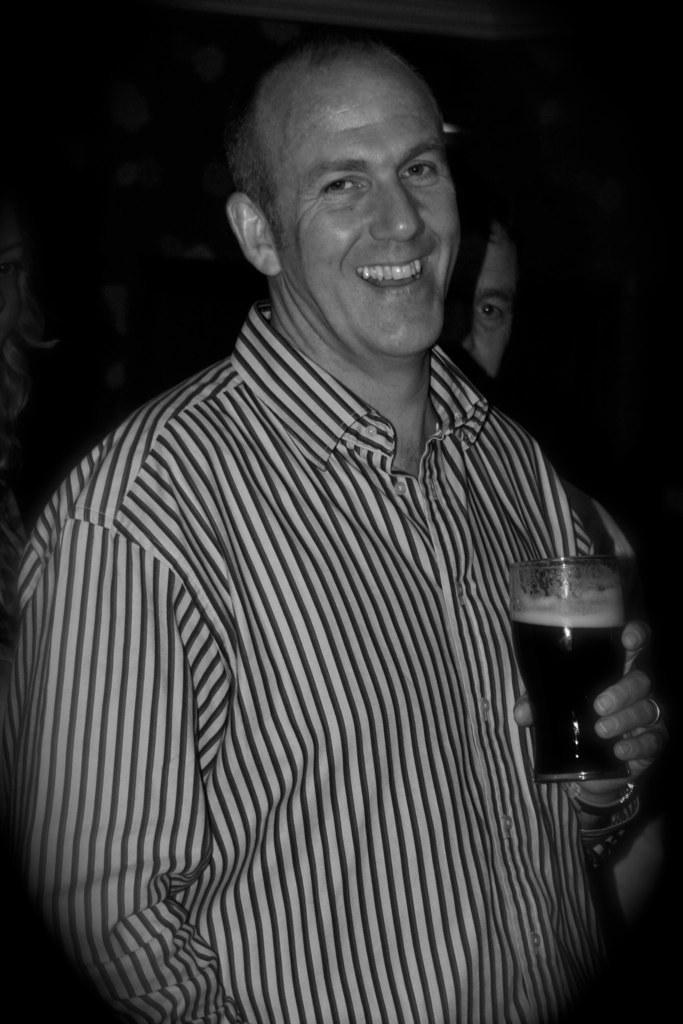Who is the main subject in the foreground of the picture? There is a person in the foreground of the picture. What is the person in the foreground holding? The person in the foreground is holding a drink. Can you describe the person behind the first person? There is another person behind the first person. What is the color of the background in the image? The background of the image is dark. What historical event is being commemorated in the image? There is no indication of a historical event being commemorated in the image. What day of the week is it in the image? The day of the week cannot be determined from the image. 